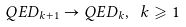Convert formula to latex. <formula><loc_0><loc_0><loc_500><loc_500>Q E D _ { k + 1 } \to Q E D _ { k } , \ k \geqslant 1</formula> 